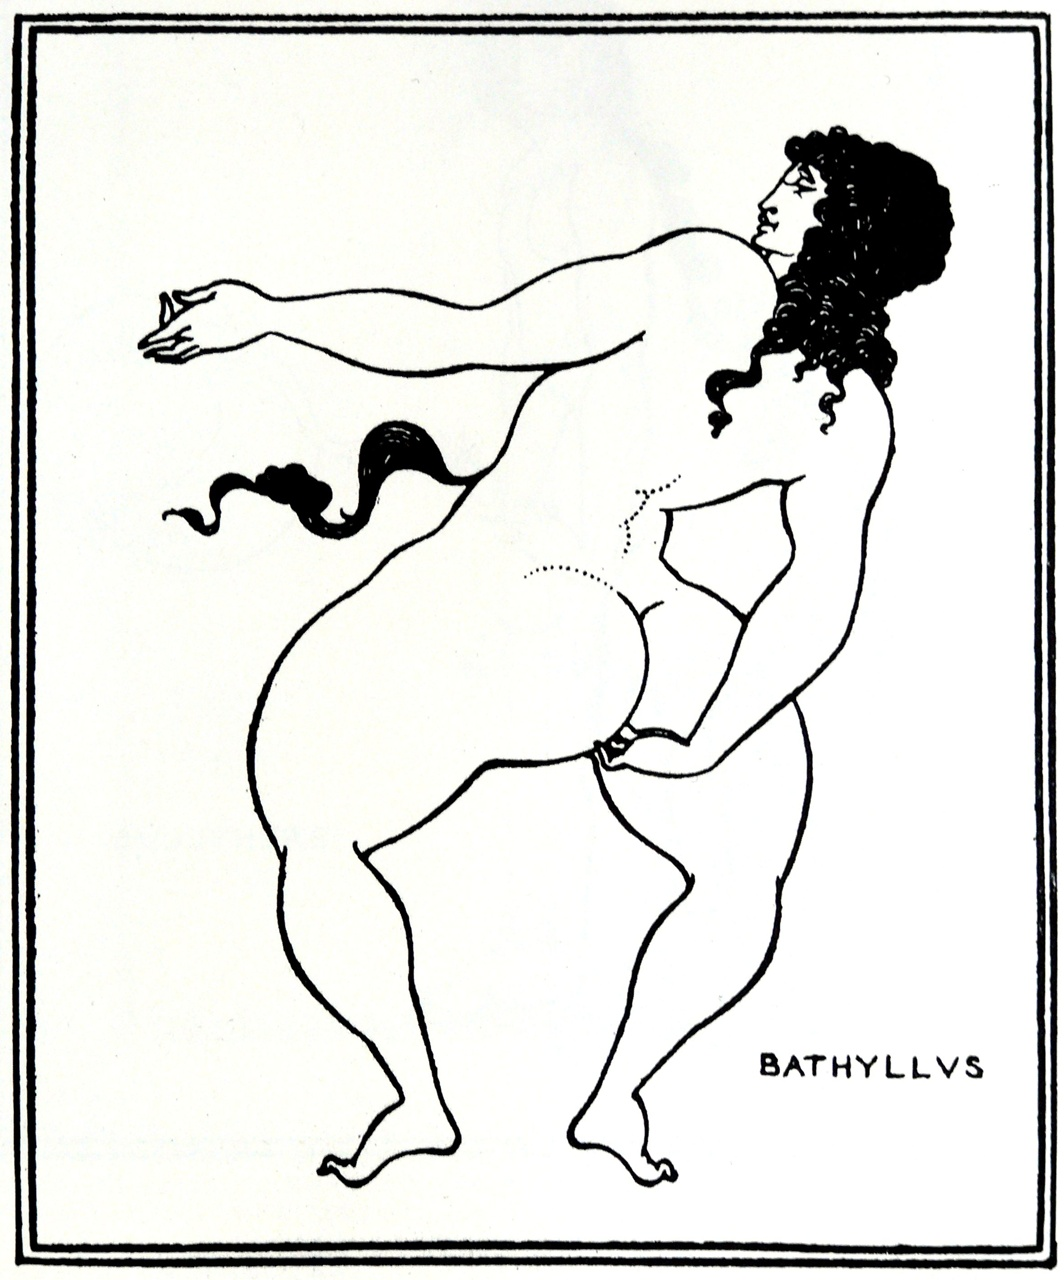Can you discuss the artistic technique used in this image? The technique used here is line art, characterized by its clear and deliberate strokes that define the contours of the figure without the use of shading. This method emphasizes clarity and form. In the context of historical artworks, such techniques were important for ensuring that the figures stood out against dark backgrounds like those of ceramic vessels, focusing on the flow of lines to convey motion and emotion. 